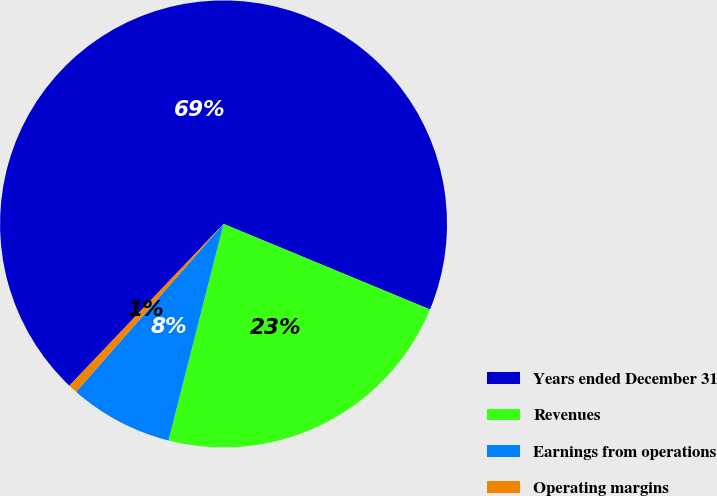Convert chart to OTSL. <chart><loc_0><loc_0><loc_500><loc_500><pie_chart><fcel>Years ended December 31<fcel>Revenues<fcel>Earnings from operations<fcel>Operating margins<nl><fcel>69.13%<fcel>22.71%<fcel>7.5%<fcel>0.65%<nl></chart> 